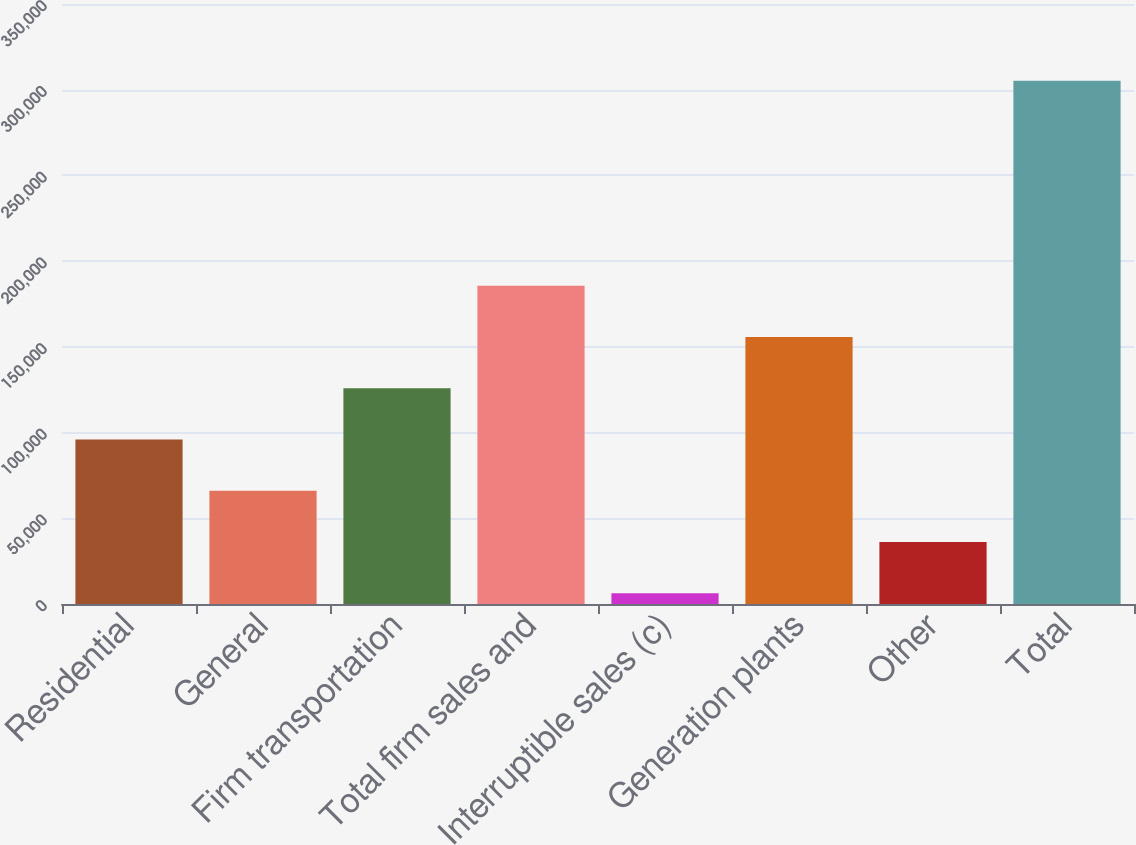<chart> <loc_0><loc_0><loc_500><loc_500><bar_chart><fcel>Residential<fcel>General<fcel>Firm transportation<fcel>Total firm sales and<fcel>Interruptible sales (c)<fcel>Generation plants<fcel>Other<fcel>Total<nl><fcel>96018.8<fcel>66123.2<fcel>125914<fcel>185706<fcel>6332<fcel>155810<fcel>36227.6<fcel>305288<nl></chart> 